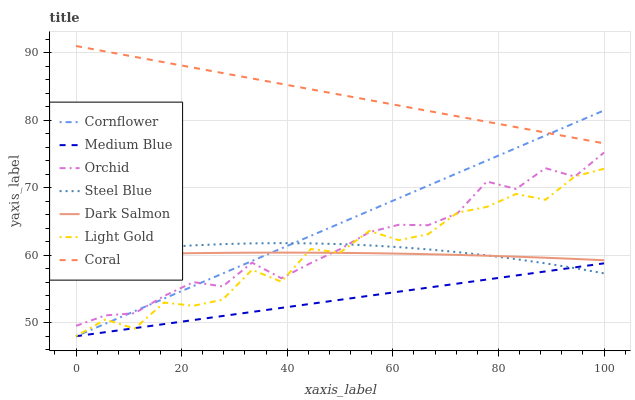Does Medium Blue have the minimum area under the curve?
Answer yes or no. Yes. Does Coral have the maximum area under the curve?
Answer yes or no. Yes. Does Coral have the minimum area under the curve?
Answer yes or no. No. Does Medium Blue have the maximum area under the curve?
Answer yes or no. No. Is Coral the smoothest?
Answer yes or no. Yes. Is Light Gold the roughest?
Answer yes or no. Yes. Is Medium Blue the smoothest?
Answer yes or no. No. Is Medium Blue the roughest?
Answer yes or no. No. Does Cornflower have the lowest value?
Answer yes or no. Yes. Does Coral have the lowest value?
Answer yes or no. No. Does Coral have the highest value?
Answer yes or no. Yes. Does Medium Blue have the highest value?
Answer yes or no. No. Is Dark Salmon less than Coral?
Answer yes or no. Yes. Is Coral greater than Dark Salmon?
Answer yes or no. Yes. Does Steel Blue intersect Cornflower?
Answer yes or no. Yes. Is Steel Blue less than Cornflower?
Answer yes or no. No. Is Steel Blue greater than Cornflower?
Answer yes or no. No. Does Dark Salmon intersect Coral?
Answer yes or no. No. 